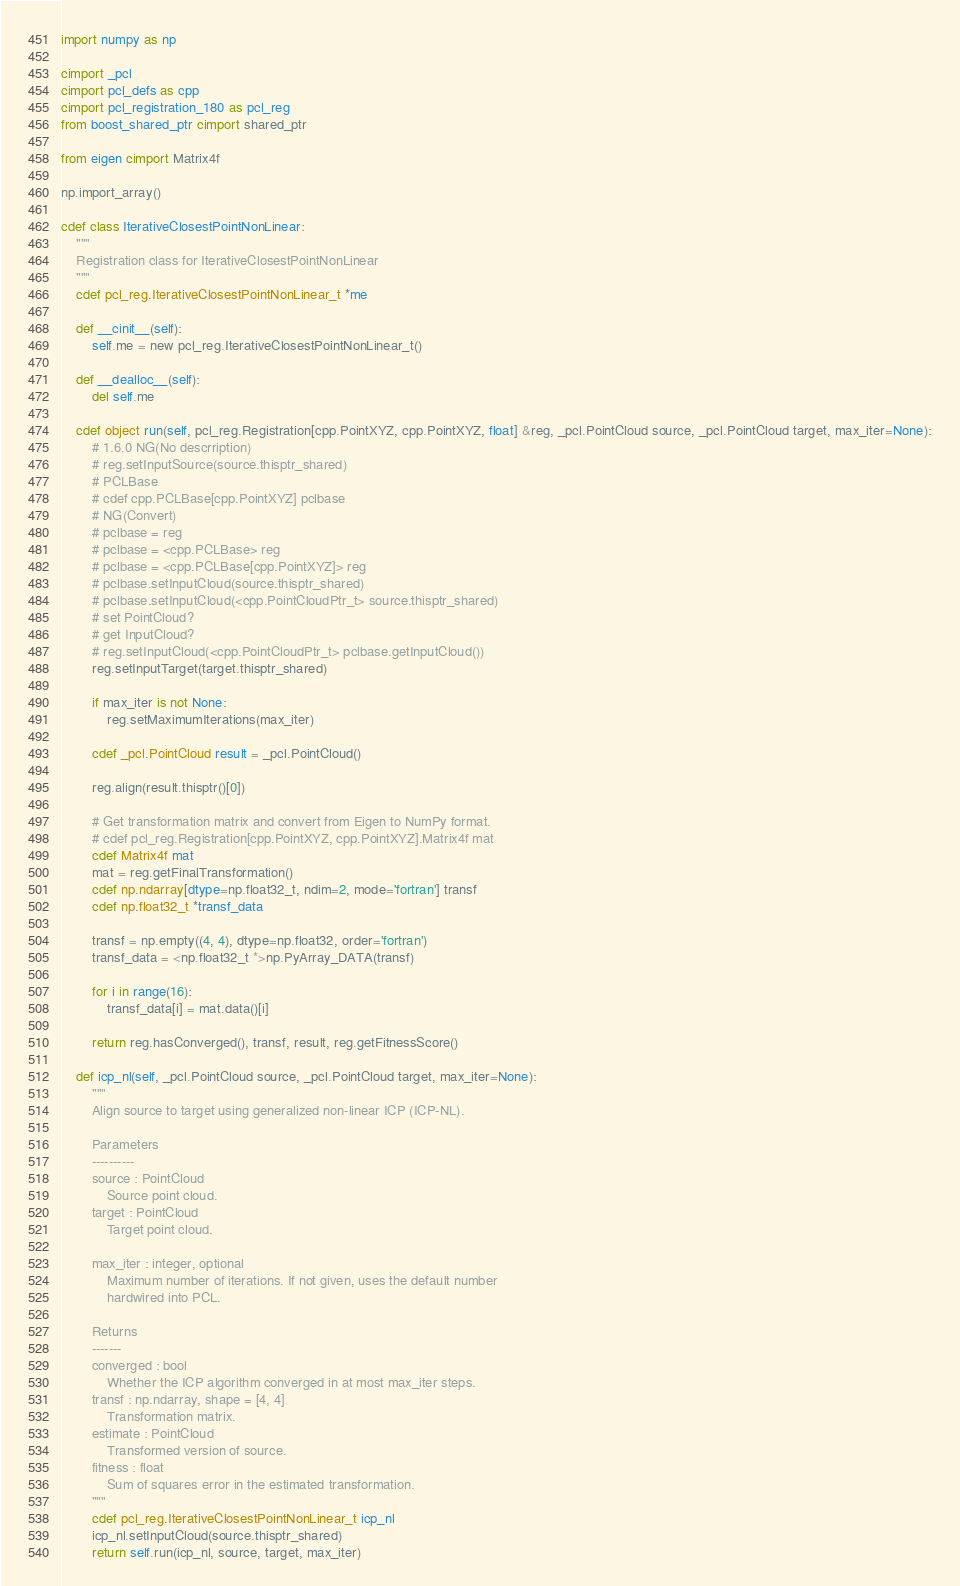<code> <loc_0><loc_0><loc_500><loc_500><_Cython_>import numpy as np

cimport _pcl
cimport pcl_defs as cpp
cimport pcl_registration_180 as pcl_reg
from boost_shared_ptr cimport shared_ptr

from eigen cimport Matrix4f

np.import_array()

cdef class IterativeClosestPointNonLinear:
    """
    Registration class for IterativeClosestPointNonLinear
    """
    cdef pcl_reg.IterativeClosestPointNonLinear_t *me

    def __cinit__(self):
        self.me = new pcl_reg.IterativeClosestPointNonLinear_t()

    def __dealloc__(self):
        del self.me

    cdef object run(self, pcl_reg.Registration[cpp.PointXYZ, cpp.PointXYZ, float] &reg, _pcl.PointCloud source, _pcl.PointCloud target, max_iter=None):
        # 1.6.0 NG(No descrription)
        # reg.setInputSource(source.thisptr_shared)
        # PCLBase
        # cdef cpp.PCLBase[cpp.PointXYZ] pclbase
        # NG(Convert)
        # pclbase = reg
        # pclbase = <cpp.PCLBase> reg
        # pclbase = <cpp.PCLBase[cpp.PointXYZ]> reg
        # pclbase.setInputCloud(source.thisptr_shared)
        # pclbase.setInputCloud(<cpp.PointCloudPtr_t> source.thisptr_shared)
        # set PointCloud?
        # get InputCloud?
        # reg.setInputCloud(<cpp.PointCloudPtr_t> pclbase.getInputCloud())
        reg.setInputTarget(target.thisptr_shared)
        
        if max_iter is not None:
            reg.setMaximumIterations(max_iter)
        
        cdef _pcl.PointCloud result = _pcl.PointCloud()
        
        reg.align(result.thisptr()[0])
        
        # Get transformation matrix and convert from Eigen to NumPy format.
        # cdef pcl_reg.Registration[cpp.PointXYZ, cpp.PointXYZ].Matrix4f mat
        cdef Matrix4f mat
        mat = reg.getFinalTransformation()
        cdef np.ndarray[dtype=np.float32_t, ndim=2, mode='fortran'] transf
        cdef np.float32_t *transf_data
        
        transf = np.empty((4, 4), dtype=np.float32, order='fortran')
        transf_data = <np.float32_t *>np.PyArray_DATA(transf)
        
        for i in range(16):
            transf_data[i] = mat.data()[i]
        
        return reg.hasConverged(), transf, result, reg.getFitnessScore()

    def icp_nl(self, _pcl.PointCloud source, _pcl.PointCloud target, max_iter=None):
        """
        Align source to target using generalized non-linear ICP (ICP-NL).
        
        Parameters
        ----------
        source : PointCloud
            Source point cloud.
        target : PointCloud
            Target point cloud.
        
        max_iter : integer, optional
            Maximum number of iterations. If not given, uses the default number
            hardwired into PCL.
        
        Returns
        -------
        converged : bool
            Whether the ICP algorithm converged in at most max_iter steps.
        transf : np.ndarray, shape = [4, 4]
            Transformation matrix.
        estimate : PointCloud
            Transformed version of source.
        fitness : float
            Sum of squares error in the estimated transformation.
        """
        cdef pcl_reg.IterativeClosestPointNonLinear_t icp_nl
        icp_nl.setInputCloud(source.thisptr_shared)
        return self.run(icp_nl, source, target, max_iter)

</code> 